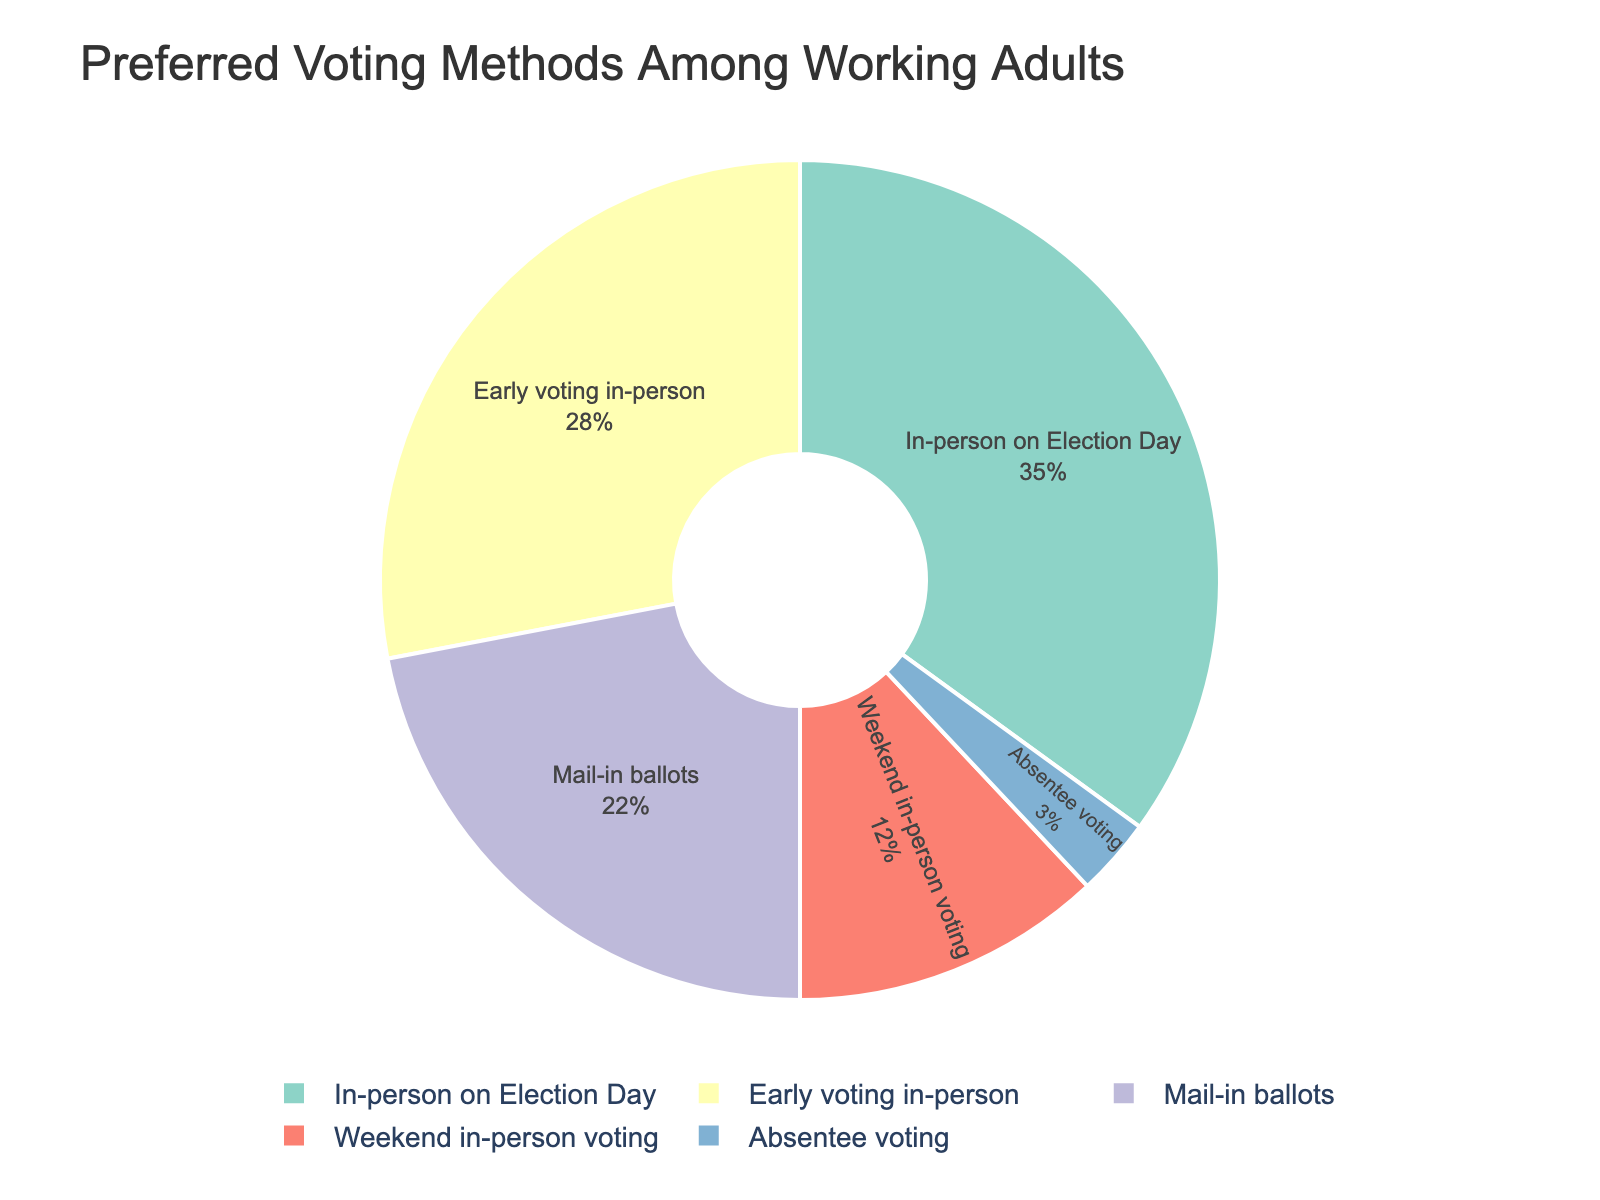What percentage of working adults prefer early voting in-person compared to mail-in ballots? First, find the percentage of working adults who prefer early voting in-person, which is 28%. Next, find the percentage for mail-in ballots, which is 22%. The difference between these is 28% - 22% = 6%.
Answer: 6% What is the total percentage of working adults who prefer weekend in-person voting or absentee voting? Combine the percentages for weekend in-person voting (12%) and absentee voting (3%). The total is 12% + 3% = 15%.
Answer: 15% Which voting method has the highest preference among working adults? Look at the percentages given for each voting method: In-person on Election Day (35%), Early voting in-person (28%), Mail-in ballots (22%), Weekend in-person voting (12%), Absentee voting (3%). In-person on Election Day has the highest percentage at 35%.
Answer: In-person on Election Day Is the sum of the percentages of early voting in-person and weekend in-person voting greater than that of mail-in ballots? The percentage for early voting in-person is 28% and for weekend in-person voting is 12%, together they sum up to 28% + 12% = 40%. The percentage for mail-in ballots is 22%. Since 40% > 22%, the sum is greater.
Answer: Yes What percentage of working adults prefer methods other than mail-in ballots? The percentage for mail-in ballots is 22%. Subtract this from the total percentage of 100% to find those who prefer other methods: 100% - 22% = 78%.
Answer: 78% How do the percentages of in-person voting methods (both on Election Day and early voting) compare to the combined percentages of mail-in ballots, weekend in-person voting, and absentee voting? Sum the percentages for in-person on Election Day (35%) and early voting in-person (28%): 35% + 28% = 63%. For the combined methods: mail-in ballots (22%), weekend in-person voting (12%), and absentee voting (3%): 22% + 12% + 3% = 37%. Since 63% > 37%, in-person voting methods are preferred by a greater percentage.
Answer: In-person voting methods are preferred What is the ratio of working adults who prefer early voting in-person to those who prefer absentee voting? The percentage for early voting in-person is 28%, and for absentee voting is 3%. The ratio is 28% / 3%. Convert the percentages into a simplifiable fraction: 28 ÷ 4 = 7 and 3 ÷ 1 = 3, so the ratio is 7:0.75 which simplifies to approximately 9.3:1
Answer: Approximately 9.3:1 Which voting method has the least preference among working adults? Compare the given percentages: In-person on Election Day (35%), Early voting in-person (28%), Mail-in ballots (22%), Weekend in-person voting (12%), and Absentee voting (3%). Absentee voting has the smallest percentage at 3%.
Answer: Absentee voting Are there more working adults who prefer to vote by mail-in ballots than those who prefer weekend in-person voting? The percentage who prefer mail-in ballots is 22%, and those who prefer weekend in-person voting is 12%. Since 22% > 12%, more prefer mail-in ballots.
Answer: Yes 